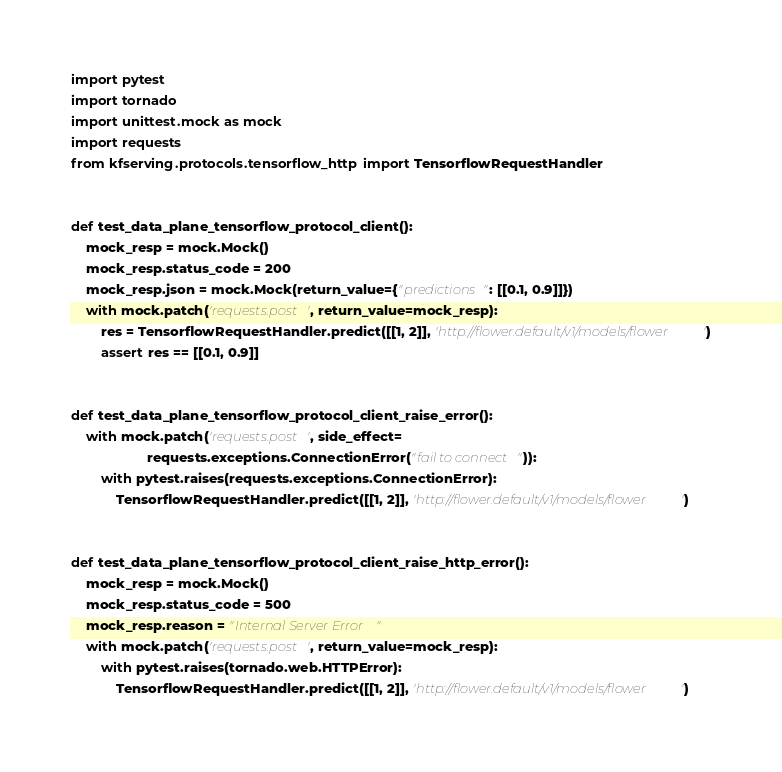Convert code to text. <code><loc_0><loc_0><loc_500><loc_500><_Python_>import pytest
import tornado
import unittest.mock as mock
import requests
from kfserving.protocols.tensorflow_http import TensorflowRequestHandler


def test_data_plane_tensorflow_protocol_client():
    mock_resp = mock.Mock()
    mock_resp.status_code = 200
    mock_resp.json = mock.Mock(return_value={"predictions": [[0.1, 0.9]]})
    with mock.patch('requests.post', return_value=mock_resp):
        res = TensorflowRequestHandler.predict([[1, 2]], 'http://flower.default/v1/models/flower')
        assert res == [[0.1, 0.9]]


def test_data_plane_tensorflow_protocol_client_raise_error():
    with mock.patch('requests.post', side_effect=
                    requests.exceptions.ConnectionError("fail to connect")):
        with pytest.raises(requests.exceptions.ConnectionError):
            TensorflowRequestHandler.predict([[1, 2]], 'http://flower.default/v1/models/flower')


def test_data_plane_tensorflow_protocol_client_raise_http_error():
    mock_resp = mock.Mock()
    mock_resp.status_code = 500
    mock_resp.reason = "Internal Server Error"
    with mock.patch('requests.post', return_value=mock_resp):
        with pytest.raises(tornado.web.HTTPError):
            TensorflowRequestHandler.predict([[1, 2]], 'http://flower.default/v1/models/flower')
</code> 